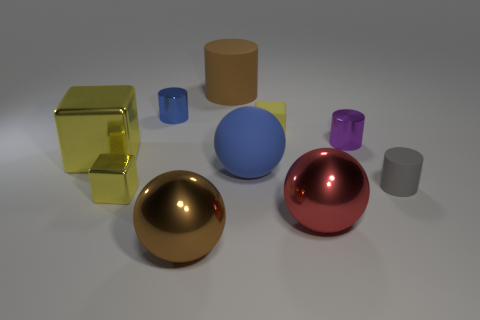Is the number of large blue rubber objects in front of the large red object the same as the number of red things?
Ensure brevity in your answer.  No. Are there any big cubes of the same color as the large matte sphere?
Provide a succinct answer. No. Is the matte cube the same size as the purple cylinder?
Provide a succinct answer. Yes. There is a rubber cylinder in front of the big shiny thing behind the blue ball; how big is it?
Your answer should be compact. Small. There is a object that is right of the blue sphere and in front of the gray thing; how big is it?
Your response must be concise. Large. What number of rubber things are the same size as the purple metal cylinder?
Offer a terse response. 2. How many matte things are either tiny green objects or red balls?
Give a very brief answer. 0. There is a matte block that is the same color as the small metal block; what size is it?
Your answer should be compact. Small. There is a yellow object right of the large brown thing in front of the blue shiny object; what is its material?
Provide a short and direct response. Rubber. How many objects are either red metal cubes or shiny cylinders to the left of the small purple metallic object?
Make the answer very short. 1. 